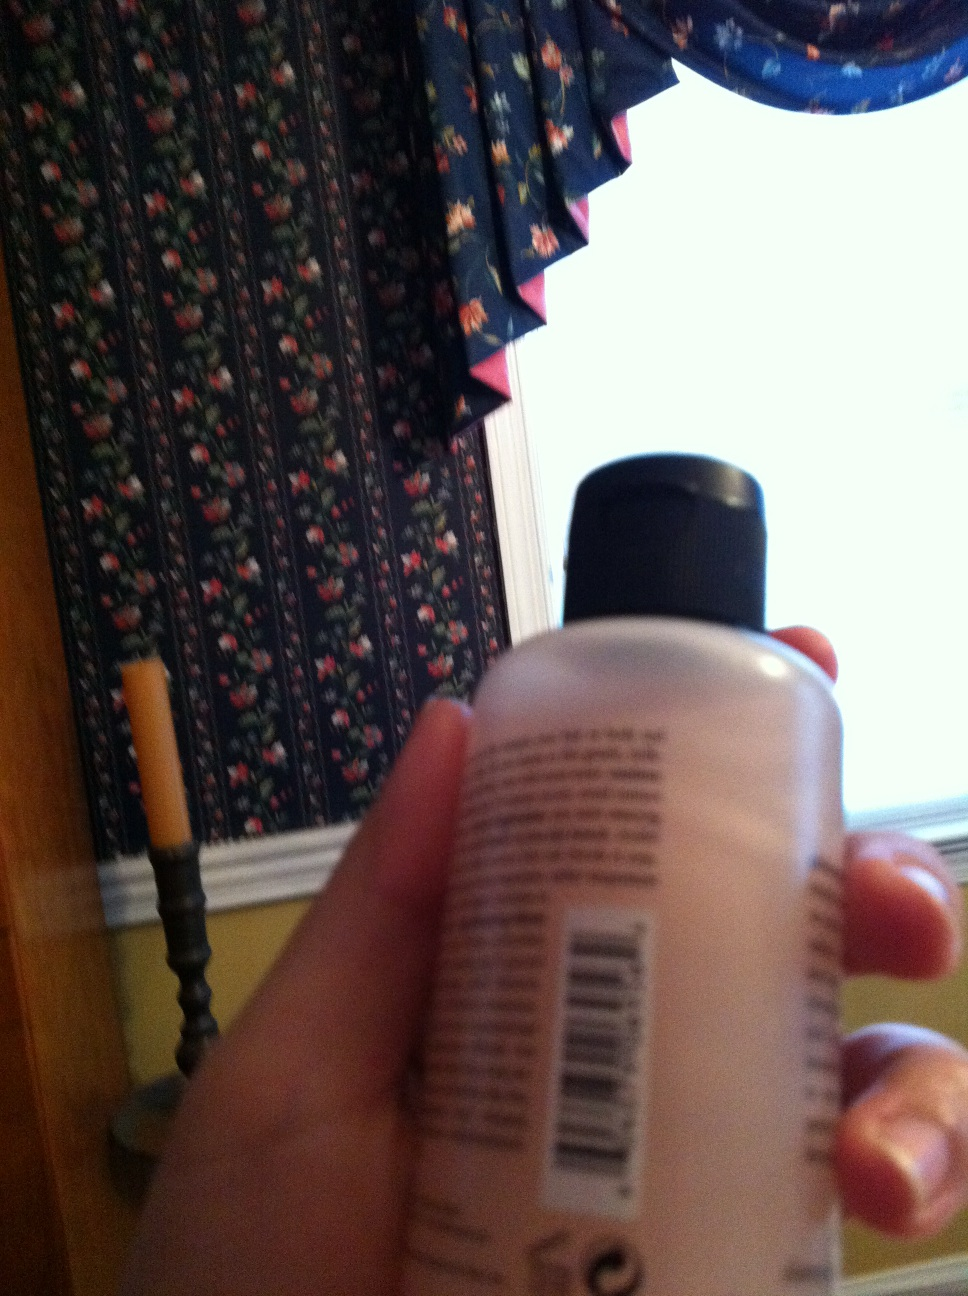Write a short dialogue between two people about the bottle in the image. Person A: "Hey, can you pass me that bottle? I need to use some lotion."
Person B: "Sure, here you go. Have you used this one before?"
Person A: "Yeah, it's really good. It keeps my skin hydrated throughout the day."
Person B: "Glad to hear that. Maybe I should try it too!" 